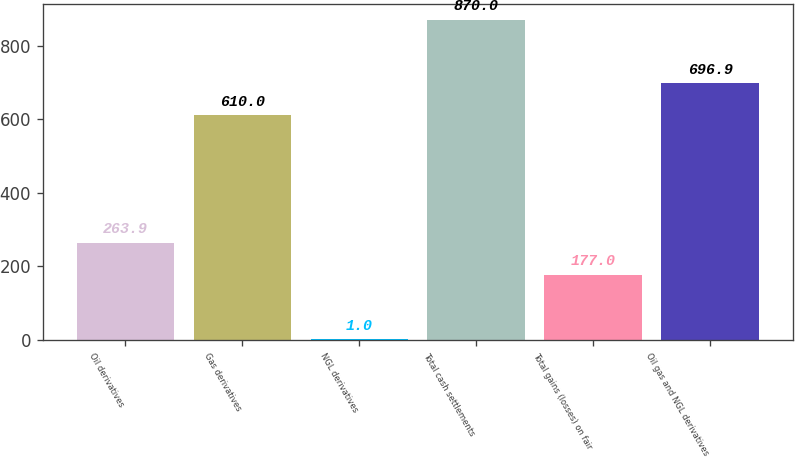<chart> <loc_0><loc_0><loc_500><loc_500><bar_chart><fcel>Oil derivatives<fcel>Gas derivatives<fcel>NGL derivatives<fcel>Total cash settlements<fcel>Total gains (losses) on fair<fcel>Oil gas and NGL derivatives<nl><fcel>263.9<fcel>610<fcel>1<fcel>870<fcel>177<fcel>696.9<nl></chart> 